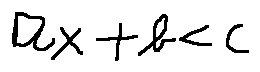Convert formula to latex. <formula><loc_0><loc_0><loc_500><loc_500>a x + b < c</formula> 